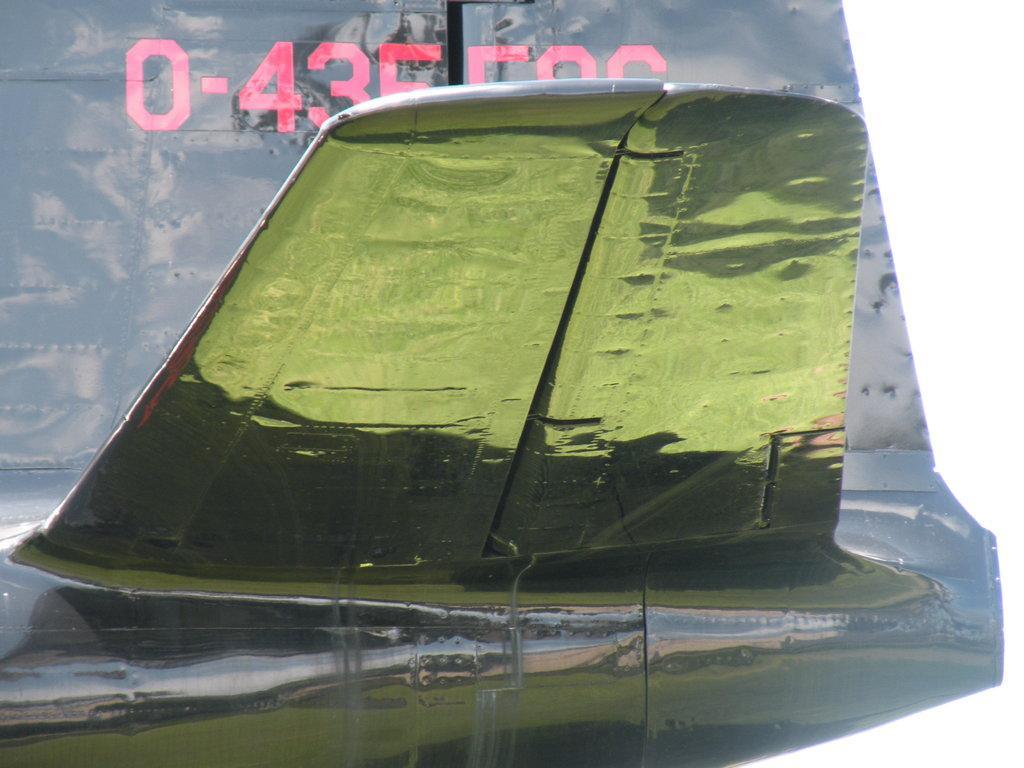How would you summarize this image in a sentence or two? In this image I can see green color thing and in the background I can see something is written. 